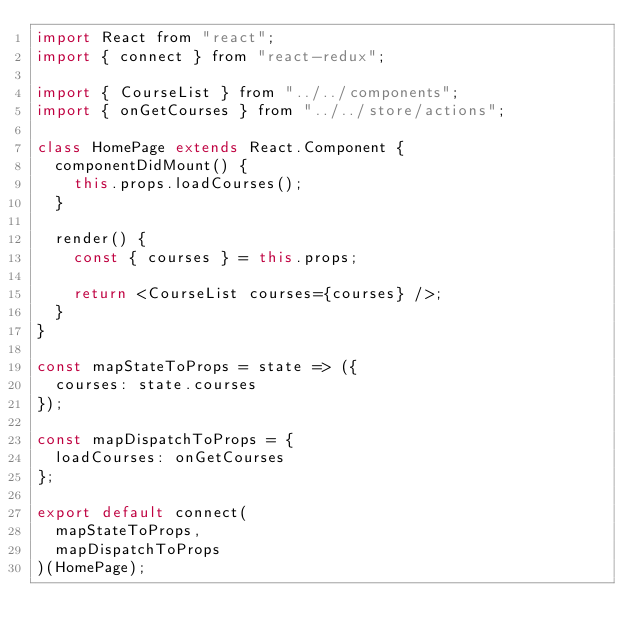<code> <loc_0><loc_0><loc_500><loc_500><_JavaScript_>import React from "react";
import { connect } from "react-redux";

import { CourseList } from "../../components";
import { onGetCourses } from "../../store/actions";

class HomePage extends React.Component {
  componentDidMount() {
    this.props.loadCourses();
  }

  render() {
    const { courses } = this.props;

    return <CourseList courses={courses} />;
  }
}

const mapStateToProps = state => ({
  courses: state.courses
});

const mapDispatchToProps = {
  loadCourses: onGetCourses
};

export default connect(
  mapStateToProps,
  mapDispatchToProps
)(HomePage);
</code> 